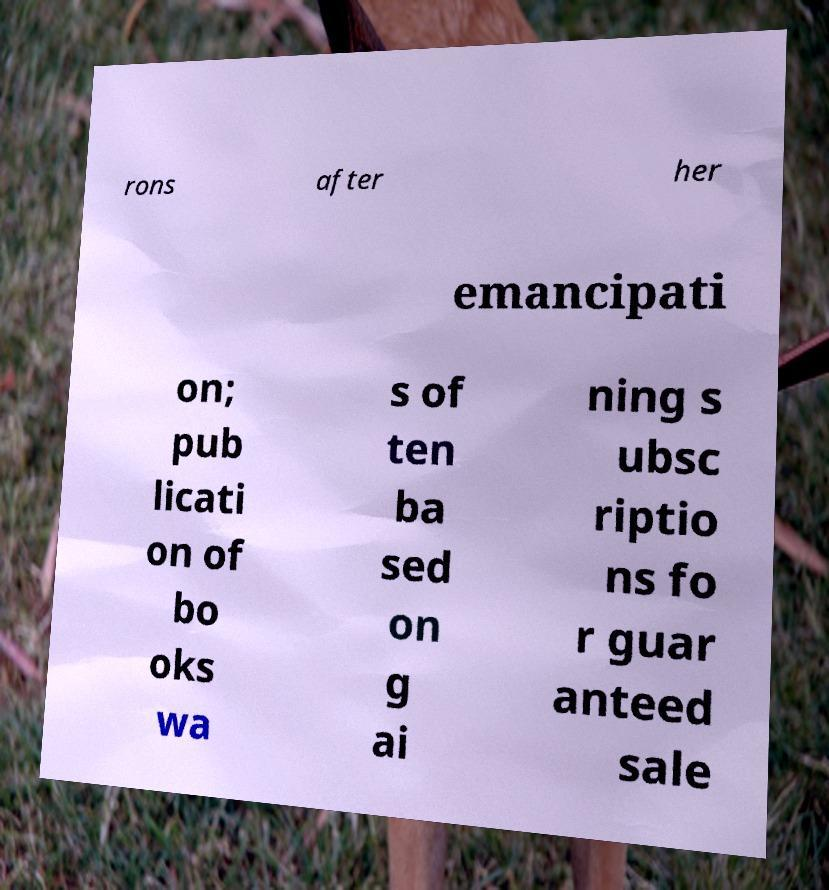I need the written content from this picture converted into text. Can you do that? rons after her emancipati on; pub licati on of bo oks wa s of ten ba sed on g ai ning s ubsc riptio ns fo r guar anteed sale 